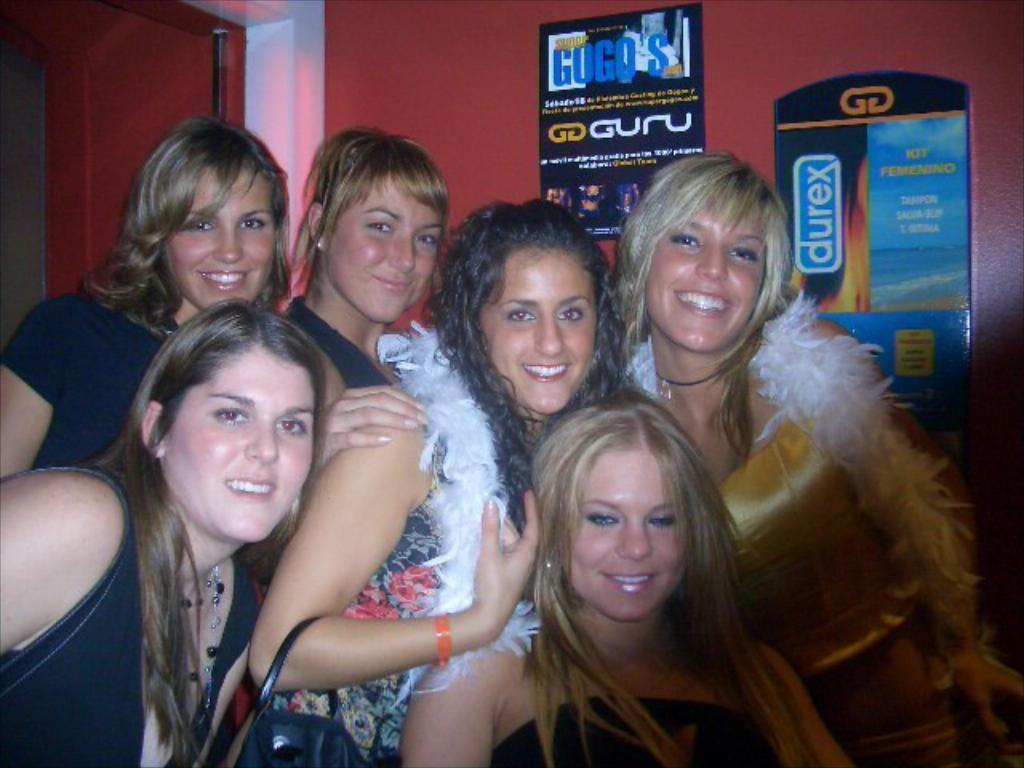What can be seen in the image? There is a group of people in the image. Can you describe the appearance of the people? The people are wearing different color dresses. What is one person doing in the image? One person is holding a bag. What can be seen in the background of the image? There are posts attached to a wall in the background of the image. What type of ear is visible on the person holding the bag in the image? There is no ear visible on the person holding the bag in the image. Is there a fireman present in the image? There is no fireman present in the image. 